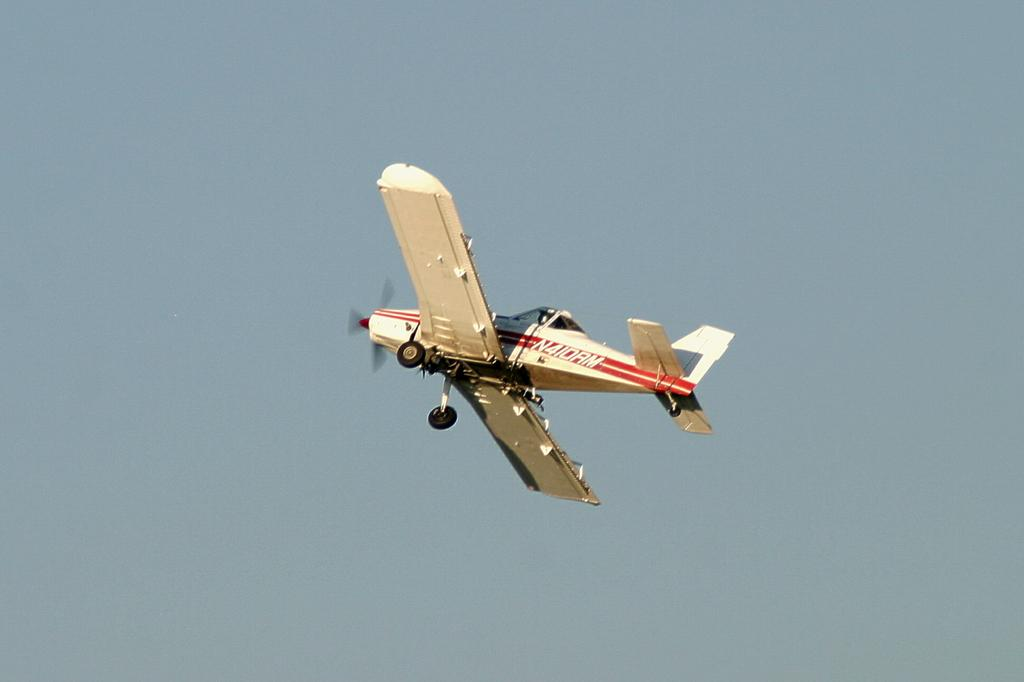What is the main subject of the image? The main subject of the image is an airplane. What is the airplane doing in the image? The airplane is flying in the sky. What type of friction is the airplane experiencing while flying in the image? There is no information about friction in the image, as airplanes typically experience air resistance rather than friction while flying. 